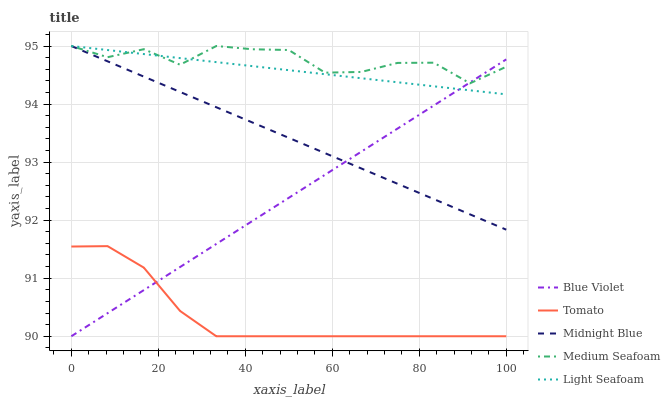Does Tomato have the minimum area under the curve?
Answer yes or no. Yes. Does Medium Seafoam have the maximum area under the curve?
Answer yes or no. Yes. Does Light Seafoam have the minimum area under the curve?
Answer yes or no. No. Does Light Seafoam have the maximum area under the curve?
Answer yes or no. No. Is Midnight Blue the smoothest?
Answer yes or no. Yes. Is Medium Seafoam the roughest?
Answer yes or no. Yes. Is Light Seafoam the smoothest?
Answer yes or no. No. Is Light Seafoam the roughest?
Answer yes or no. No. Does Tomato have the lowest value?
Answer yes or no. Yes. Does Light Seafoam have the lowest value?
Answer yes or no. No. Does Medium Seafoam have the highest value?
Answer yes or no. Yes. Does Blue Violet have the highest value?
Answer yes or no. No. Is Tomato less than Light Seafoam?
Answer yes or no. Yes. Is Midnight Blue greater than Tomato?
Answer yes or no. Yes. Does Light Seafoam intersect Midnight Blue?
Answer yes or no. Yes. Is Light Seafoam less than Midnight Blue?
Answer yes or no. No. Is Light Seafoam greater than Midnight Blue?
Answer yes or no. No. Does Tomato intersect Light Seafoam?
Answer yes or no. No. 